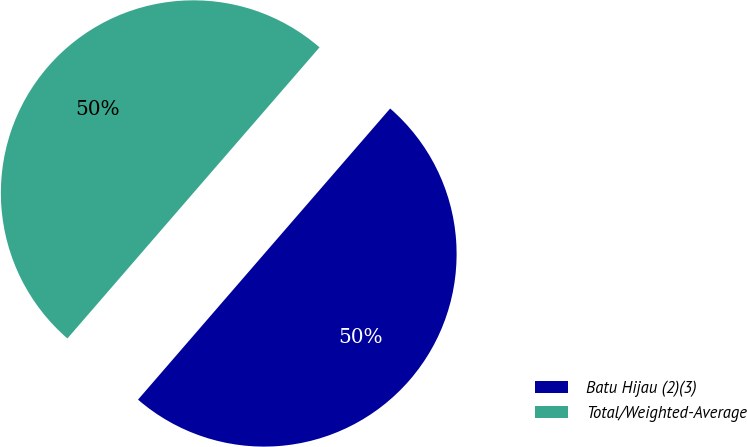<chart> <loc_0><loc_0><loc_500><loc_500><pie_chart><fcel>Batu Hijau (2)(3)<fcel>Total/Weighted-Average<nl><fcel>49.99%<fcel>50.01%<nl></chart> 